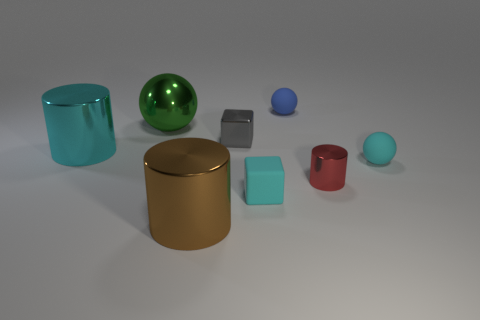Can you speculate on the purpose of this arrangement of objects? This scene seems to be a geometric study or a visual demonstration, aimed at showcasing various shapes and colors. The arrangement might be for a graphical design presentation, 3D modeling exercise, or even a lighting and shading test in computer graphics, highlighting how different surfaces interact with light. Which object stands out the most, and why? The large green sphere stands out due to its size, bright color, and central position in the image. Its reflective surface also catches the eye as it contrasts sharply with both the matte and differently shaded objects surrounding it, making it a focal point. 